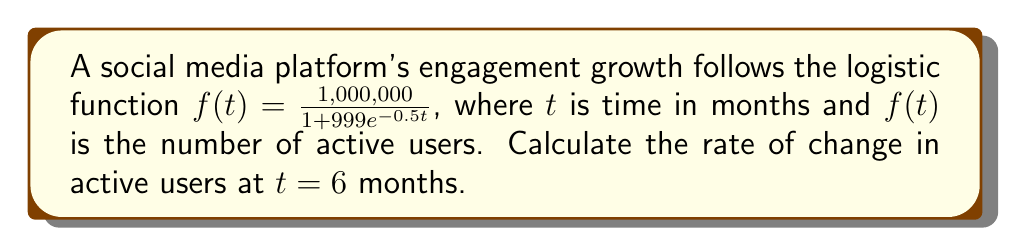Provide a solution to this math problem. To find the rate of change at $t = 6$ months, we need to differentiate the logistic function and evaluate it at $t = 6$. Let's break this down step-by-step:

1) The logistic function is given by:
   $$f(t) = \frac{1,000,000}{1 + 999e^{-0.5t}}$$

2) To find the derivative, we use the quotient rule:
   $$f'(t) = \frac{u'v - uv'}{v^2}$$
   where $u = 1,000,000$ and $v = 1 + 999e^{-0.5t}$

3) Calculate $u'$ and $v'$:
   $u' = 0$ (constant)
   $v' = 999 \cdot (-0.5) \cdot e^{-0.5t} = -499.5e^{-0.5t}$

4) Apply the quotient rule:
   $$f'(t) = \frac{0 \cdot (1 + 999e^{-0.5t}) - 1,000,000 \cdot (-499.5e^{-0.5t})}{(1 + 999e^{-0.5t})^2}$$

5) Simplify:
   $$f'(t) = \frac{499,500,000e^{-0.5t}}{(1 + 999e^{-0.5t})^2}$$

6) Now, evaluate at $t = 6$:
   $$f'(6) = \frac{499,500,000e^{-0.5 \cdot 6}}{(1 + 999e^{-0.5 \cdot 6})^2}$$

7) Calculate $e^{-0.5 \cdot 6} \approx 0.0497$:
   $$f'(6) \approx \frac{499,500,000 \cdot 0.0497}{(1 + 999 \cdot 0.0497)^2} \approx 41,244$$

Therefore, the rate of change in active users at 6 months is approximately 41,244 users per month.
Answer: 41,244 users/month 